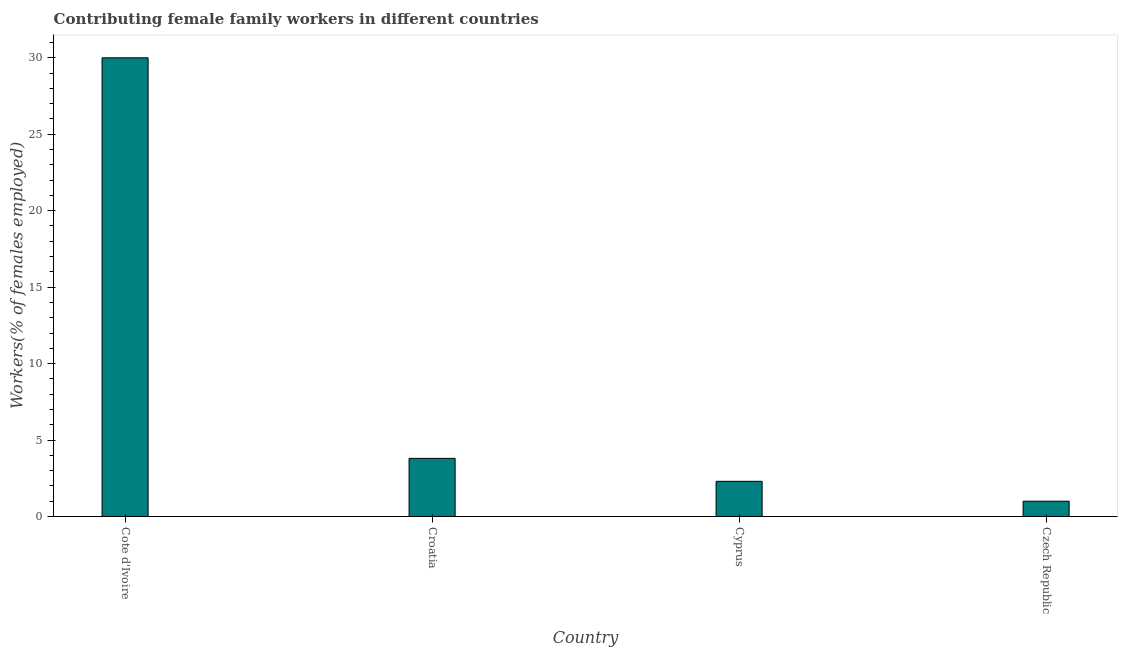Does the graph contain any zero values?
Your response must be concise. No. What is the title of the graph?
Provide a succinct answer. Contributing female family workers in different countries. What is the label or title of the Y-axis?
Your answer should be very brief. Workers(% of females employed). Across all countries, what is the maximum contributing female family workers?
Your answer should be compact. 30. Across all countries, what is the minimum contributing female family workers?
Keep it short and to the point. 1. In which country was the contributing female family workers maximum?
Ensure brevity in your answer.  Cote d'Ivoire. In which country was the contributing female family workers minimum?
Your answer should be very brief. Czech Republic. What is the sum of the contributing female family workers?
Provide a short and direct response. 37.1. What is the difference between the contributing female family workers in Croatia and Czech Republic?
Make the answer very short. 2.8. What is the average contributing female family workers per country?
Ensure brevity in your answer.  9.28. What is the median contributing female family workers?
Provide a short and direct response. 3.05. In how many countries, is the contributing female family workers greater than 28 %?
Offer a terse response. 1. What is the ratio of the contributing female family workers in Cote d'Ivoire to that in Croatia?
Make the answer very short. 7.89. What is the difference between the highest and the second highest contributing female family workers?
Your answer should be very brief. 26.2. How many countries are there in the graph?
Make the answer very short. 4. What is the Workers(% of females employed) of Croatia?
Your answer should be very brief. 3.8. What is the Workers(% of females employed) in Cyprus?
Make the answer very short. 2.3. What is the difference between the Workers(% of females employed) in Cote d'Ivoire and Croatia?
Your response must be concise. 26.2. What is the difference between the Workers(% of females employed) in Cote d'Ivoire and Cyprus?
Make the answer very short. 27.7. What is the difference between the Workers(% of females employed) in Cote d'Ivoire and Czech Republic?
Give a very brief answer. 29. What is the difference between the Workers(% of females employed) in Croatia and Cyprus?
Offer a terse response. 1.5. What is the difference between the Workers(% of females employed) in Croatia and Czech Republic?
Ensure brevity in your answer.  2.8. What is the difference between the Workers(% of females employed) in Cyprus and Czech Republic?
Provide a succinct answer. 1.3. What is the ratio of the Workers(% of females employed) in Cote d'Ivoire to that in Croatia?
Your response must be concise. 7.89. What is the ratio of the Workers(% of females employed) in Cote d'Ivoire to that in Cyprus?
Ensure brevity in your answer.  13.04. What is the ratio of the Workers(% of females employed) in Cote d'Ivoire to that in Czech Republic?
Provide a succinct answer. 30. What is the ratio of the Workers(% of females employed) in Croatia to that in Cyprus?
Ensure brevity in your answer.  1.65. What is the ratio of the Workers(% of females employed) in Croatia to that in Czech Republic?
Offer a terse response. 3.8. What is the ratio of the Workers(% of females employed) in Cyprus to that in Czech Republic?
Keep it short and to the point. 2.3. 